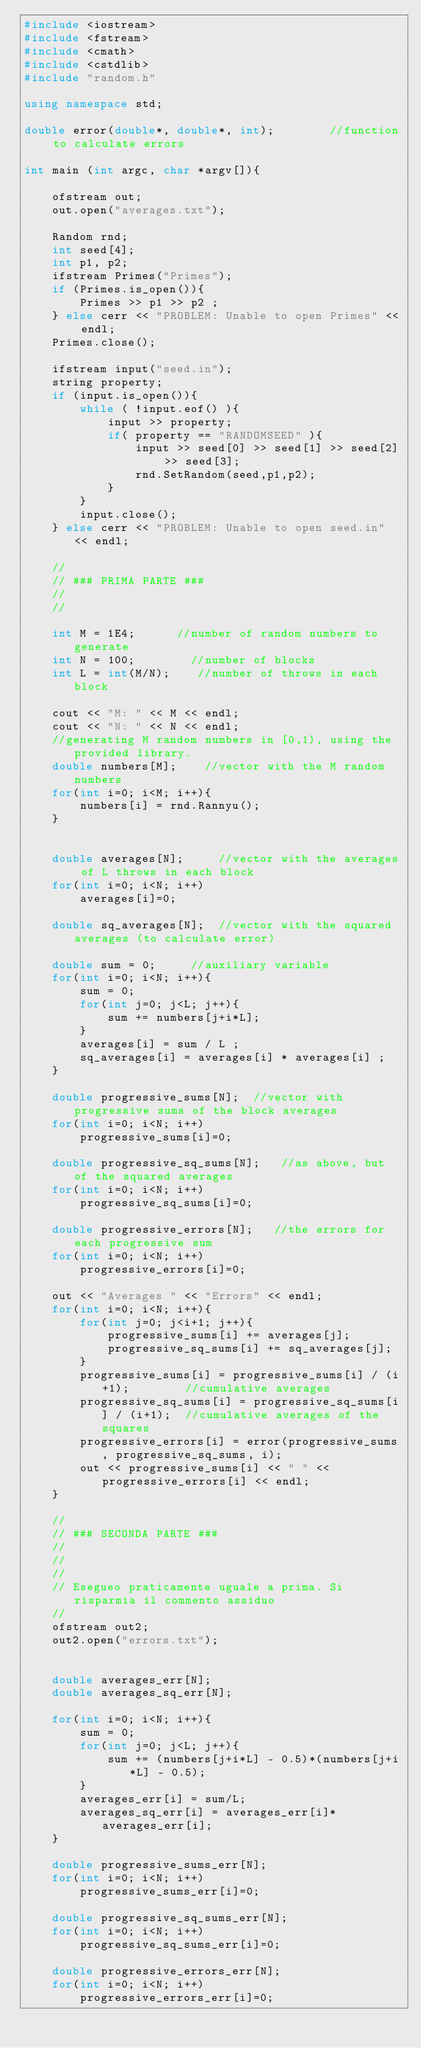<code> <loc_0><loc_0><loc_500><loc_500><_C++_>#include <iostream>
#include <fstream>
#include <cmath>
#include <cstdlib>
#include "random.h"

using namespace std;

double error(double*, double*, int);        //function to calculate errors

int main (int argc, char *argv[]){
    
    ofstream out;
    out.open("averages.txt");
    
    Random rnd;
    int seed[4];
    int p1, p2;
    ifstream Primes("Primes");
    if (Primes.is_open()){
        Primes >> p1 >> p2 ;
    } else cerr << "PROBLEM: Unable to open Primes" << endl;
    Primes.close();
    
    ifstream input("seed.in");
    string property;
    if (input.is_open()){
        while ( !input.eof() ){
            input >> property;
            if( property == "RANDOMSEED" ){
                input >> seed[0] >> seed[1] >> seed[2] >> seed[3];
                rnd.SetRandom(seed,p1,p2);
            }
        }
        input.close();
    } else cerr << "PROBLEM: Unable to open seed.in" << endl;
    
    //
    // ### PRIMA PARTE ###
    //
    //
    
    int M = 1E4;      //number of random numbers to generate
    int N = 100;        //number of blocks
    int L = int(M/N);    //number of throws in each block
    
    cout << "M: " << M << endl;
    cout << "N: " << N << endl;
    //generating M random numbers in [0,1), using the provided library.
    double numbers[M];    //vector with the M random numbers
    for(int i=0; i<M; i++){
        numbers[i] = rnd.Rannyu();
    }
    
    
    double averages[N];     //vector with the averages of L throws in each block
    for(int i=0; i<N; i++)
        averages[i]=0;
        
    double sq_averages[N];  //vector with the squared averages (to calculate error)
    
    double sum = 0;     //auxiliary variable
    for(int i=0; i<N; i++){
        sum = 0;
        for(int j=0; j<L; j++){
            sum += numbers[j+i*L];
        }
        averages[i] = sum / L ;
        sq_averages[i] = averages[i] * averages[i] ;
    }
    
    double progressive_sums[N];  //vector with progressive sums of the block averages
    for(int i=0; i<N; i++)
        progressive_sums[i]=0;
    
    double progressive_sq_sums[N];   //as above, but of the squared averages
    for(int i=0; i<N; i++)
        progressive_sq_sums[i]=0;
    
    double progressive_errors[N];   //the errors for each progressive sum
    for(int i=0; i<N; i++)
        progressive_errors[i]=0;
    
    out << "Averages " << "Errors" << endl;
    for(int i=0; i<N; i++){
        for(int j=0; j<i+1; j++){
            progressive_sums[i] += averages[j];
            progressive_sq_sums[i] += sq_averages[j];
        }
        progressive_sums[i] = progressive_sums[i] / (i+1);        //cumulative averages
        progressive_sq_sums[i] = progressive_sq_sums[i] / (i+1);  //cumulative averages of the squares
        progressive_errors[i] = error(progressive_sums, progressive_sq_sums, i);
        out << progressive_sums[i] << " " << progressive_errors[i] << endl;
    }
    
    //
    // ### SECONDA PARTE ###
    //
    //
    //
    // Esegueo praticamente uguale a prima. Si risparmia il commento assiduo
    //
    ofstream out2;
    out2.open("errors.txt");
    
    
    double averages_err[N];
    double averages_sq_err[N];
    
    for(int i=0; i<N; i++){
        sum = 0;
        for(int j=0; j<L; j++){
            sum += (numbers[j+i*L] - 0.5)*(numbers[j+i*L] - 0.5);
        }
        averages_err[i] = sum/L;
        averages_sq_err[i] = averages_err[i]*averages_err[i];
    }
    
    double progressive_sums_err[N];
    for(int i=0; i<N; i++)
        progressive_sums_err[i]=0;
    
    double progressive_sq_sums_err[N];
    for(int i=0; i<N; i++)
        progressive_sq_sums_err[i]=0;
    
    double progressive_errors_err[N];
    for(int i=0; i<N; i++)
        progressive_errors_err[i]=0;
    </code> 